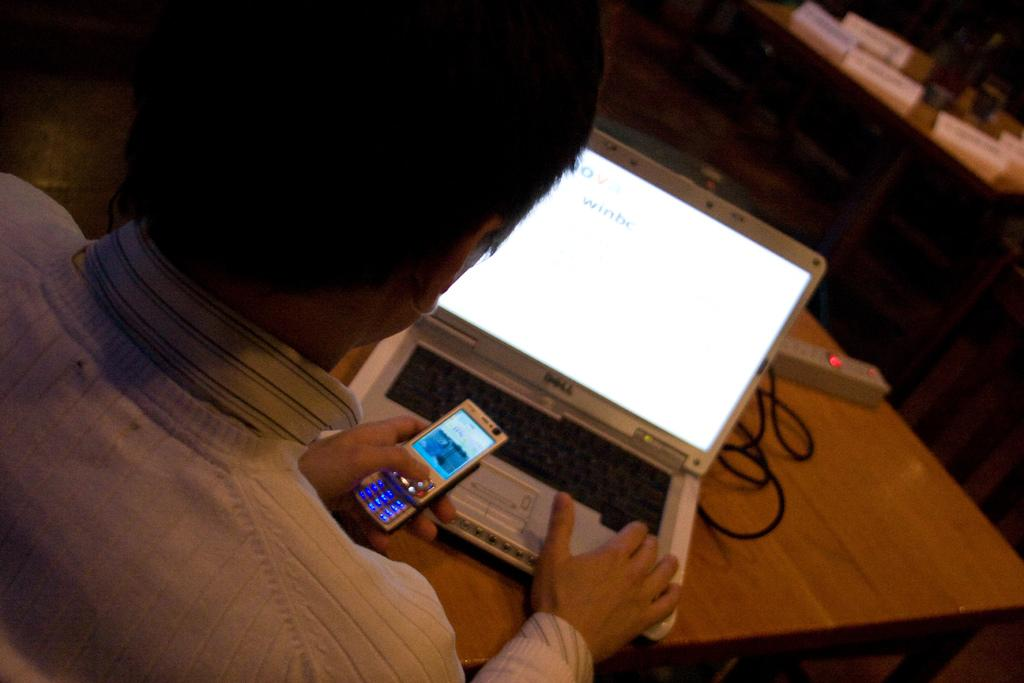Provide a one-sentence caption for the provided image. A man types something into a Dell product while holding his cell phone. 